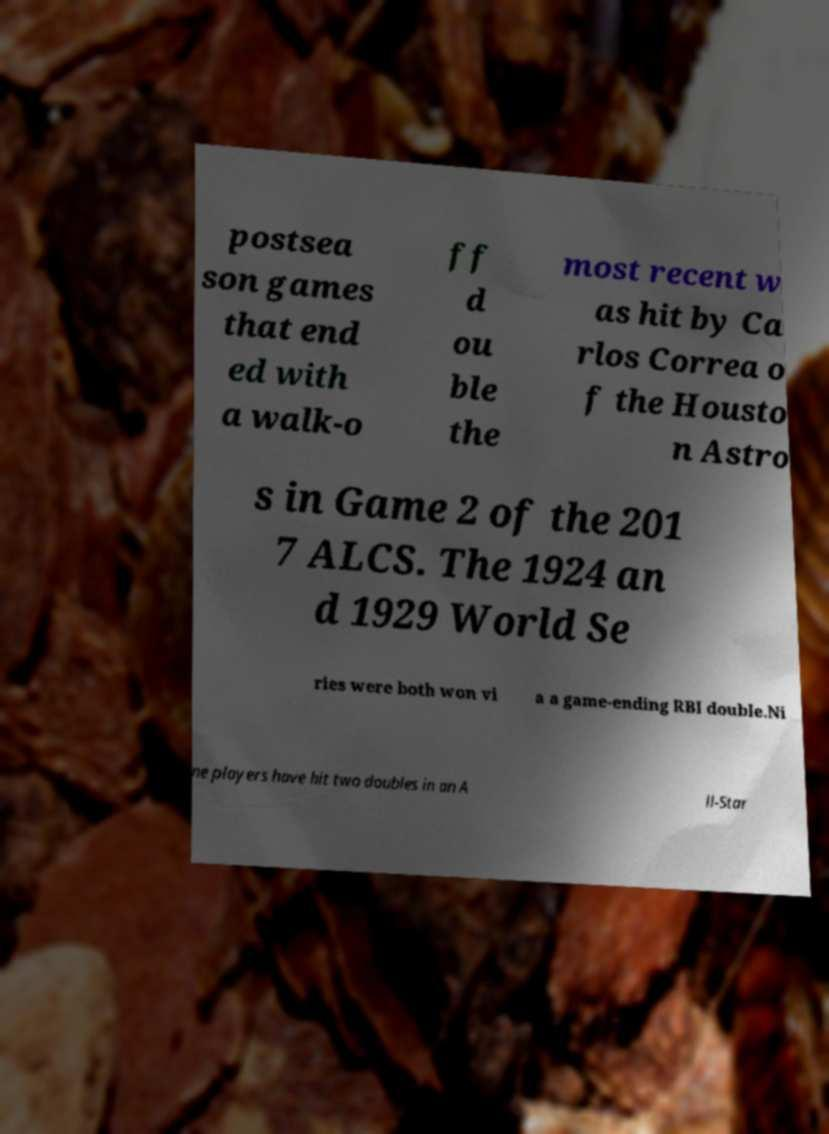There's text embedded in this image that I need extracted. Can you transcribe it verbatim? postsea son games that end ed with a walk-o ff d ou ble the most recent w as hit by Ca rlos Correa o f the Housto n Astro s in Game 2 of the 201 7 ALCS. The 1924 an d 1929 World Se ries were both won vi a a game-ending RBI double.Ni ne players have hit two doubles in an A ll-Star 